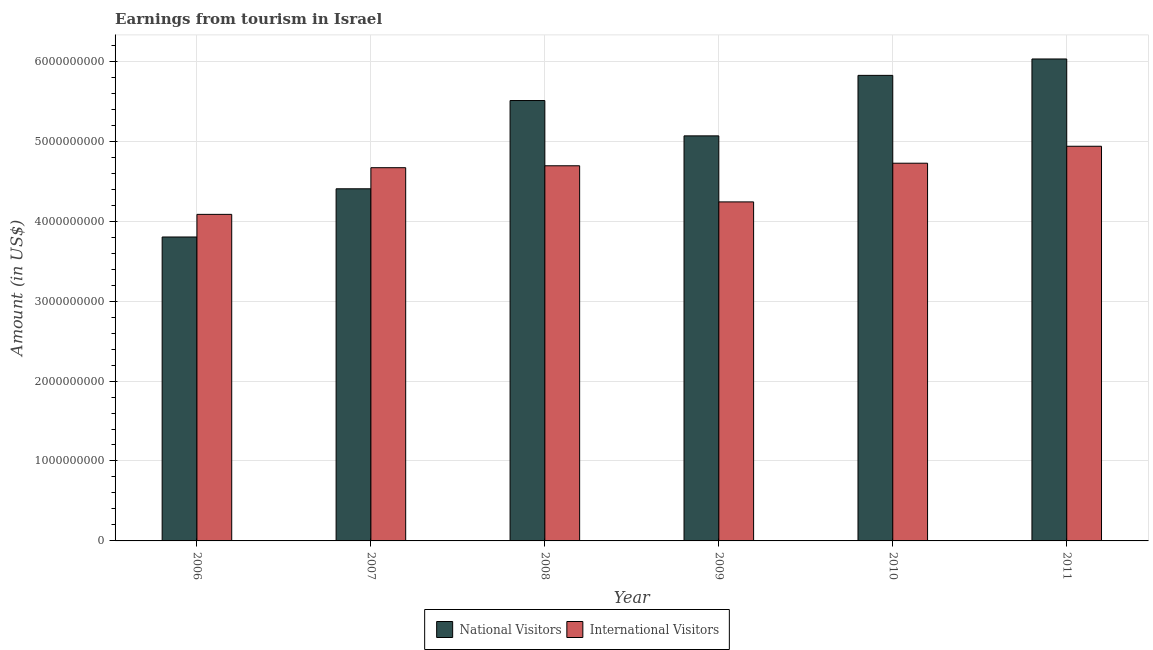How many different coloured bars are there?
Your answer should be very brief. 2. Are the number of bars per tick equal to the number of legend labels?
Provide a short and direct response. Yes. Are the number of bars on each tick of the X-axis equal?
Provide a succinct answer. Yes. How many bars are there on the 1st tick from the left?
Provide a succinct answer. 2. What is the amount earned from international visitors in 2006?
Offer a terse response. 4.08e+09. Across all years, what is the maximum amount earned from national visitors?
Your answer should be very brief. 6.03e+09. Across all years, what is the minimum amount earned from international visitors?
Offer a very short reply. 4.08e+09. In which year was the amount earned from international visitors minimum?
Offer a very short reply. 2006. What is the total amount earned from national visitors in the graph?
Give a very brief answer. 3.06e+1. What is the difference between the amount earned from national visitors in 2007 and that in 2009?
Ensure brevity in your answer.  -6.62e+08. What is the difference between the amount earned from international visitors in 2007 and the amount earned from national visitors in 2009?
Your answer should be very brief. 4.28e+08. What is the average amount earned from national visitors per year?
Ensure brevity in your answer.  5.11e+09. In the year 2006, what is the difference between the amount earned from international visitors and amount earned from national visitors?
Make the answer very short. 0. In how many years, is the amount earned from national visitors greater than 5400000000 US$?
Provide a succinct answer. 3. What is the ratio of the amount earned from national visitors in 2008 to that in 2010?
Ensure brevity in your answer.  0.95. Is the difference between the amount earned from international visitors in 2006 and 2007 greater than the difference between the amount earned from national visitors in 2006 and 2007?
Ensure brevity in your answer.  No. What is the difference between the highest and the second highest amount earned from international visitors?
Your response must be concise. 2.12e+08. What is the difference between the highest and the lowest amount earned from international visitors?
Keep it short and to the point. 8.52e+08. Is the sum of the amount earned from national visitors in 2006 and 2009 greater than the maximum amount earned from international visitors across all years?
Ensure brevity in your answer.  Yes. What does the 1st bar from the left in 2010 represents?
Your answer should be compact. National Visitors. What does the 2nd bar from the right in 2011 represents?
Offer a terse response. National Visitors. How many bars are there?
Keep it short and to the point. 12. Are the values on the major ticks of Y-axis written in scientific E-notation?
Ensure brevity in your answer.  No. Does the graph contain any zero values?
Provide a short and direct response. No. Does the graph contain grids?
Offer a terse response. Yes. How many legend labels are there?
Provide a short and direct response. 2. How are the legend labels stacked?
Provide a succinct answer. Horizontal. What is the title of the graph?
Provide a short and direct response. Earnings from tourism in Israel. What is the Amount (in US$) in National Visitors in 2006?
Give a very brief answer. 3.80e+09. What is the Amount (in US$) in International Visitors in 2006?
Your answer should be very brief. 4.08e+09. What is the Amount (in US$) in National Visitors in 2007?
Your answer should be compact. 4.40e+09. What is the Amount (in US$) of International Visitors in 2007?
Give a very brief answer. 4.67e+09. What is the Amount (in US$) of National Visitors in 2008?
Give a very brief answer. 5.51e+09. What is the Amount (in US$) in International Visitors in 2008?
Offer a very short reply. 4.69e+09. What is the Amount (in US$) of National Visitors in 2009?
Keep it short and to the point. 5.07e+09. What is the Amount (in US$) of International Visitors in 2009?
Make the answer very short. 4.24e+09. What is the Amount (in US$) of National Visitors in 2010?
Offer a terse response. 5.82e+09. What is the Amount (in US$) in International Visitors in 2010?
Provide a short and direct response. 4.72e+09. What is the Amount (in US$) of National Visitors in 2011?
Provide a succinct answer. 6.03e+09. What is the Amount (in US$) in International Visitors in 2011?
Your answer should be very brief. 4.94e+09. Across all years, what is the maximum Amount (in US$) of National Visitors?
Offer a very short reply. 6.03e+09. Across all years, what is the maximum Amount (in US$) of International Visitors?
Your answer should be very brief. 4.94e+09. Across all years, what is the minimum Amount (in US$) of National Visitors?
Offer a very short reply. 3.80e+09. Across all years, what is the minimum Amount (in US$) of International Visitors?
Your response must be concise. 4.08e+09. What is the total Amount (in US$) in National Visitors in the graph?
Provide a short and direct response. 3.06e+1. What is the total Amount (in US$) of International Visitors in the graph?
Give a very brief answer. 2.74e+1. What is the difference between the Amount (in US$) of National Visitors in 2006 and that in 2007?
Your response must be concise. -6.03e+08. What is the difference between the Amount (in US$) in International Visitors in 2006 and that in 2007?
Ensure brevity in your answer.  -5.84e+08. What is the difference between the Amount (in US$) in National Visitors in 2006 and that in 2008?
Provide a succinct answer. -1.71e+09. What is the difference between the Amount (in US$) of International Visitors in 2006 and that in 2008?
Make the answer very short. -6.08e+08. What is the difference between the Amount (in US$) in National Visitors in 2006 and that in 2009?
Your response must be concise. -1.26e+09. What is the difference between the Amount (in US$) in International Visitors in 2006 and that in 2009?
Offer a terse response. -1.56e+08. What is the difference between the Amount (in US$) of National Visitors in 2006 and that in 2010?
Ensure brevity in your answer.  -2.02e+09. What is the difference between the Amount (in US$) of International Visitors in 2006 and that in 2010?
Give a very brief answer. -6.40e+08. What is the difference between the Amount (in US$) of National Visitors in 2006 and that in 2011?
Your response must be concise. -2.23e+09. What is the difference between the Amount (in US$) of International Visitors in 2006 and that in 2011?
Provide a succinct answer. -8.52e+08. What is the difference between the Amount (in US$) in National Visitors in 2007 and that in 2008?
Offer a very short reply. -1.10e+09. What is the difference between the Amount (in US$) in International Visitors in 2007 and that in 2008?
Provide a succinct answer. -2.40e+07. What is the difference between the Amount (in US$) of National Visitors in 2007 and that in 2009?
Provide a short and direct response. -6.62e+08. What is the difference between the Amount (in US$) of International Visitors in 2007 and that in 2009?
Offer a terse response. 4.28e+08. What is the difference between the Amount (in US$) in National Visitors in 2007 and that in 2010?
Your answer should be very brief. -1.42e+09. What is the difference between the Amount (in US$) of International Visitors in 2007 and that in 2010?
Give a very brief answer. -5.60e+07. What is the difference between the Amount (in US$) in National Visitors in 2007 and that in 2011?
Provide a short and direct response. -1.62e+09. What is the difference between the Amount (in US$) in International Visitors in 2007 and that in 2011?
Ensure brevity in your answer.  -2.68e+08. What is the difference between the Amount (in US$) of National Visitors in 2008 and that in 2009?
Make the answer very short. 4.42e+08. What is the difference between the Amount (in US$) in International Visitors in 2008 and that in 2009?
Ensure brevity in your answer.  4.52e+08. What is the difference between the Amount (in US$) of National Visitors in 2008 and that in 2010?
Provide a succinct answer. -3.15e+08. What is the difference between the Amount (in US$) in International Visitors in 2008 and that in 2010?
Give a very brief answer. -3.20e+07. What is the difference between the Amount (in US$) in National Visitors in 2008 and that in 2011?
Make the answer very short. -5.20e+08. What is the difference between the Amount (in US$) of International Visitors in 2008 and that in 2011?
Make the answer very short. -2.44e+08. What is the difference between the Amount (in US$) in National Visitors in 2009 and that in 2010?
Keep it short and to the point. -7.57e+08. What is the difference between the Amount (in US$) in International Visitors in 2009 and that in 2010?
Keep it short and to the point. -4.84e+08. What is the difference between the Amount (in US$) in National Visitors in 2009 and that in 2011?
Offer a very short reply. -9.62e+08. What is the difference between the Amount (in US$) of International Visitors in 2009 and that in 2011?
Provide a succinct answer. -6.96e+08. What is the difference between the Amount (in US$) of National Visitors in 2010 and that in 2011?
Provide a short and direct response. -2.05e+08. What is the difference between the Amount (in US$) in International Visitors in 2010 and that in 2011?
Give a very brief answer. -2.12e+08. What is the difference between the Amount (in US$) in National Visitors in 2006 and the Amount (in US$) in International Visitors in 2007?
Your answer should be compact. -8.67e+08. What is the difference between the Amount (in US$) in National Visitors in 2006 and the Amount (in US$) in International Visitors in 2008?
Provide a short and direct response. -8.91e+08. What is the difference between the Amount (in US$) of National Visitors in 2006 and the Amount (in US$) of International Visitors in 2009?
Your response must be concise. -4.39e+08. What is the difference between the Amount (in US$) in National Visitors in 2006 and the Amount (in US$) in International Visitors in 2010?
Provide a succinct answer. -9.23e+08. What is the difference between the Amount (in US$) in National Visitors in 2006 and the Amount (in US$) in International Visitors in 2011?
Your response must be concise. -1.14e+09. What is the difference between the Amount (in US$) of National Visitors in 2007 and the Amount (in US$) of International Visitors in 2008?
Provide a succinct answer. -2.88e+08. What is the difference between the Amount (in US$) of National Visitors in 2007 and the Amount (in US$) of International Visitors in 2009?
Keep it short and to the point. 1.64e+08. What is the difference between the Amount (in US$) of National Visitors in 2007 and the Amount (in US$) of International Visitors in 2010?
Offer a very short reply. -3.20e+08. What is the difference between the Amount (in US$) of National Visitors in 2007 and the Amount (in US$) of International Visitors in 2011?
Give a very brief answer. -5.32e+08. What is the difference between the Amount (in US$) of National Visitors in 2008 and the Amount (in US$) of International Visitors in 2009?
Your response must be concise. 1.27e+09. What is the difference between the Amount (in US$) in National Visitors in 2008 and the Amount (in US$) in International Visitors in 2010?
Your answer should be compact. 7.84e+08. What is the difference between the Amount (in US$) of National Visitors in 2008 and the Amount (in US$) of International Visitors in 2011?
Provide a short and direct response. 5.72e+08. What is the difference between the Amount (in US$) in National Visitors in 2009 and the Amount (in US$) in International Visitors in 2010?
Make the answer very short. 3.42e+08. What is the difference between the Amount (in US$) in National Visitors in 2009 and the Amount (in US$) in International Visitors in 2011?
Offer a terse response. 1.30e+08. What is the difference between the Amount (in US$) in National Visitors in 2010 and the Amount (in US$) in International Visitors in 2011?
Provide a short and direct response. 8.87e+08. What is the average Amount (in US$) of National Visitors per year?
Provide a short and direct response. 5.11e+09. What is the average Amount (in US$) in International Visitors per year?
Offer a very short reply. 4.56e+09. In the year 2006, what is the difference between the Amount (in US$) of National Visitors and Amount (in US$) of International Visitors?
Keep it short and to the point. -2.83e+08. In the year 2007, what is the difference between the Amount (in US$) of National Visitors and Amount (in US$) of International Visitors?
Give a very brief answer. -2.64e+08. In the year 2008, what is the difference between the Amount (in US$) of National Visitors and Amount (in US$) of International Visitors?
Your response must be concise. 8.16e+08. In the year 2009, what is the difference between the Amount (in US$) of National Visitors and Amount (in US$) of International Visitors?
Keep it short and to the point. 8.26e+08. In the year 2010, what is the difference between the Amount (in US$) of National Visitors and Amount (in US$) of International Visitors?
Offer a very short reply. 1.10e+09. In the year 2011, what is the difference between the Amount (in US$) of National Visitors and Amount (in US$) of International Visitors?
Your answer should be very brief. 1.09e+09. What is the ratio of the Amount (in US$) in National Visitors in 2006 to that in 2007?
Offer a very short reply. 0.86. What is the ratio of the Amount (in US$) in International Visitors in 2006 to that in 2007?
Provide a short and direct response. 0.87. What is the ratio of the Amount (in US$) in National Visitors in 2006 to that in 2008?
Ensure brevity in your answer.  0.69. What is the ratio of the Amount (in US$) of International Visitors in 2006 to that in 2008?
Provide a succinct answer. 0.87. What is the ratio of the Amount (in US$) of National Visitors in 2006 to that in 2009?
Your answer should be very brief. 0.75. What is the ratio of the Amount (in US$) in International Visitors in 2006 to that in 2009?
Offer a very short reply. 0.96. What is the ratio of the Amount (in US$) in National Visitors in 2006 to that in 2010?
Provide a short and direct response. 0.65. What is the ratio of the Amount (in US$) in International Visitors in 2006 to that in 2010?
Offer a very short reply. 0.86. What is the ratio of the Amount (in US$) in National Visitors in 2006 to that in 2011?
Your answer should be compact. 0.63. What is the ratio of the Amount (in US$) of International Visitors in 2006 to that in 2011?
Your answer should be compact. 0.83. What is the ratio of the Amount (in US$) of National Visitors in 2007 to that in 2008?
Provide a short and direct response. 0.8. What is the ratio of the Amount (in US$) in International Visitors in 2007 to that in 2008?
Ensure brevity in your answer.  0.99. What is the ratio of the Amount (in US$) of National Visitors in 2007 to that in 2009?
Your response must be concise. 0.87. What is the ratio of the Amount (in US$) in International Visitors in 2007 to that in 2009?
Ensure brevity in your answer.  1.1. What is the ratio of the Amount (in US$) in National Visitors in 2007 to that in 2010?
Keep it short and to the point. 0.76. What is the ratio of the Amount (in US$) of International Visitors in 2007 to that in 2010?
Provide a short and direct response. 0.99. What is the ratio of the Amount (in US$) in National Visitors in 2007 to that in 2011?
Provide a succinct answer. 0.73. What is the ratio of the Amount (in US$) of International Visitors in 2007 to that in 2011?
Make the answer very short. 0.95. What is the ratio of the Amount (in US$) of National Visitors in 2008 to that in 2009?
Make the answer very short. 1.09. What is the ratio of the Amount (in US$) of International Visitors in 2008 to that in 2009?
Offer a terse response. 1.11. What is the ratio of the Amount (in US$) of National Visitors in 2008 to that in 2010?
Offer a very short reply. 0.95. What is the ratio of the Amount (in US$) of National Visitors in 2008 to that in 2011?
Your answer should be compact. 0.91. What is the ratio of the Amount (in US$) of International Visitors in 2008 to that in 2011?
Make the answer very short. 0.95. What is the ratio of the Amount (in US$) in National Visitors in 2009 to that in 2010?
Keep it short and to the point. 0.87. What is the ratio of the Amount (in US$) of International Visitors in 2009 to that in 2010?
Ensure brevity in your answer.  0.9. What is the ratio of the Amount (in US$) in National Visitors in 2009 to that in 2011?
Your response must be concise. 0.84. What is the ratio of the Amount (in US$) in International Visitors in 2009 to that in 2011?
Provide a short and direct response. 0.86. What is the ratio of the Amount (in US$) of International Visitors in 2010 to that in 2011?
Offer a terse response. 0.96. What is the difference between the highest and the second highest Amount (in US$) in National Visitors?
Make the answer very short. 2.05e+08. What is the difference between the highest and the second highest Amount (in US$) of International Visitors?
Give a very brief answer. 2.12e+08. What is the difference between the highest and the lowest Amount (in US$) of National Visitors?
Offer a very short reply. 2.23e+09. What is the difference between the highest and the lowest Amount (in US$) of International Visitors?
Offer a very short reply. 8.52e+08. 